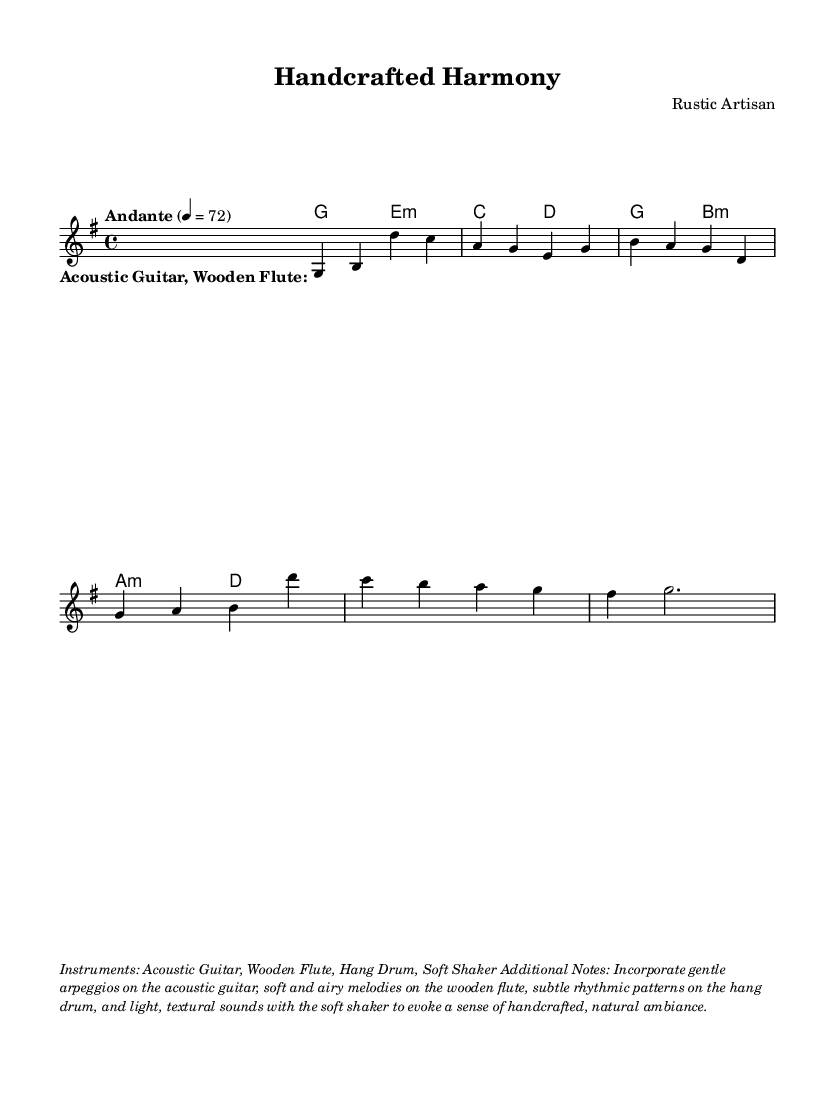What is the key signature of this music? The key signature is G major, which has one sharp (F#). You can identify this in the global section where it states "\key g \major".
Answer: G major What is the time signature of the music? The time signature is indicated as 4/4 in the global section of the code. It shows that there are four beats per measure and a quarter note gets one beat.
Answer: 4/4 What is the tempo marking for this piece? The tempo marking is "Andante" and the metronome marking is set to quarter note equals 72. This indicates a moderately slow tempo.
Answer: Andante, 72 How many instruments are indicated in the markup? The instruments listed in the markup are Acoustic Guitar, Wooden Flute, Hang Drum, and Soft Shaker. This indicates four different instruments to be used.
Answer: Four What type of music does this piece represent? This piece represents relaxing instrumental music inspired by rustic, handmade objects. This is inferred from the instruments used and the instructions in the markup section.
Answer: Relaxing instrumental music What is the structure of the melody in terms of measures? The melody consists of five measures as grouped in the music notation. Each set of notes divided by the vertical lines represents a single measure.
Answer: Five measures What lyric pattern is structured in the song? The lyrics are structured as a single stanza with no specific words provided, just an indication for the instrumentation. This shows a focus on the musical composition rather than lyrical content.
Answer: One stanza 